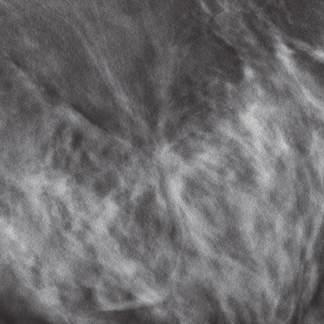what often appear as relatively subtle, irregular masses in mammograms?
Answer the question using a single word or phrase. Lobular carcinomas 